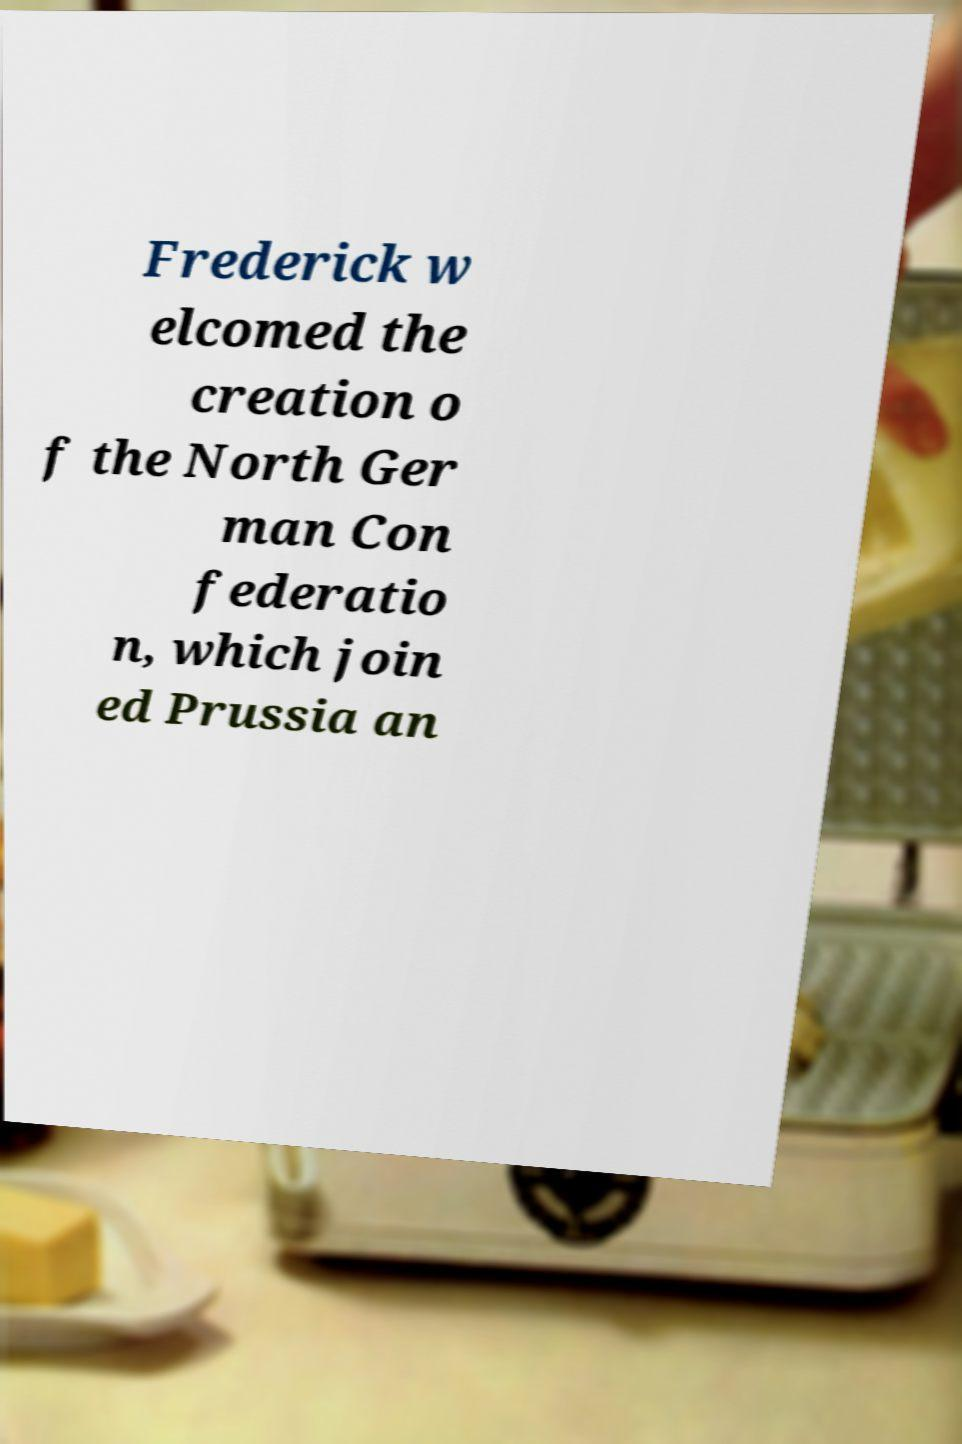Can you read and provide the text displayed in the image?This photo seems to have some interesting text. Can you extract and type it out for me? Frederick w elcomed the creation o f the North Ger man Con federatio n, which join ed Prussia an 